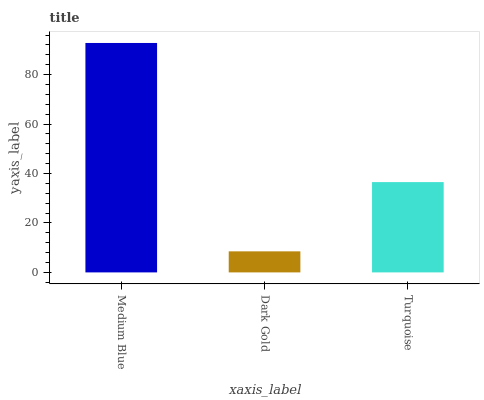Is Dark Gold the minimum?
Answer yes or no. Yes. Is Medium Blue the maximum?
Answer yes or no. Yes. Is Turquoise the minimum?
Answer yes or no. No. Is Turquoise the maximum?
Answer yes or no. No. Is Turquoise greater than Dark Gold?
Answer yes or no. Yes. Is Dark Gold less than Turquoise?
Answer yes or no. Yes. Is Dark Gold greater than Turquoise?
Answer yes or no. No. Is Turquoise less than Dark Gold?
Answer yes or no. No. Is Turquoise the high median?
Answer yes or no. Yes. Is Turquoise the low median?
Answer yes or no. Yes. Is Medium Blue the high median?
Answer yes or no. No. Is Dark Gold the low median?
Answer yes or no. No. 